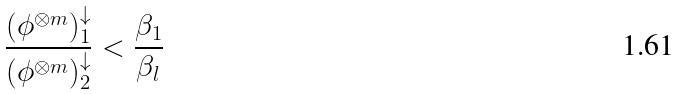Convert formula to latex. <formula><loc_0><loc_0><loc_500><loc_500>\frac { { ( \phi ^ { \otimes m } ) ^ { \downarrow } _ { 1 } } } { { ( \phi ^ { \otimes m } ) ^ { \downarrow } _ { 2 } } } < \frac { \beta _ { 1 } } { \beta _ { l } }</formula> 